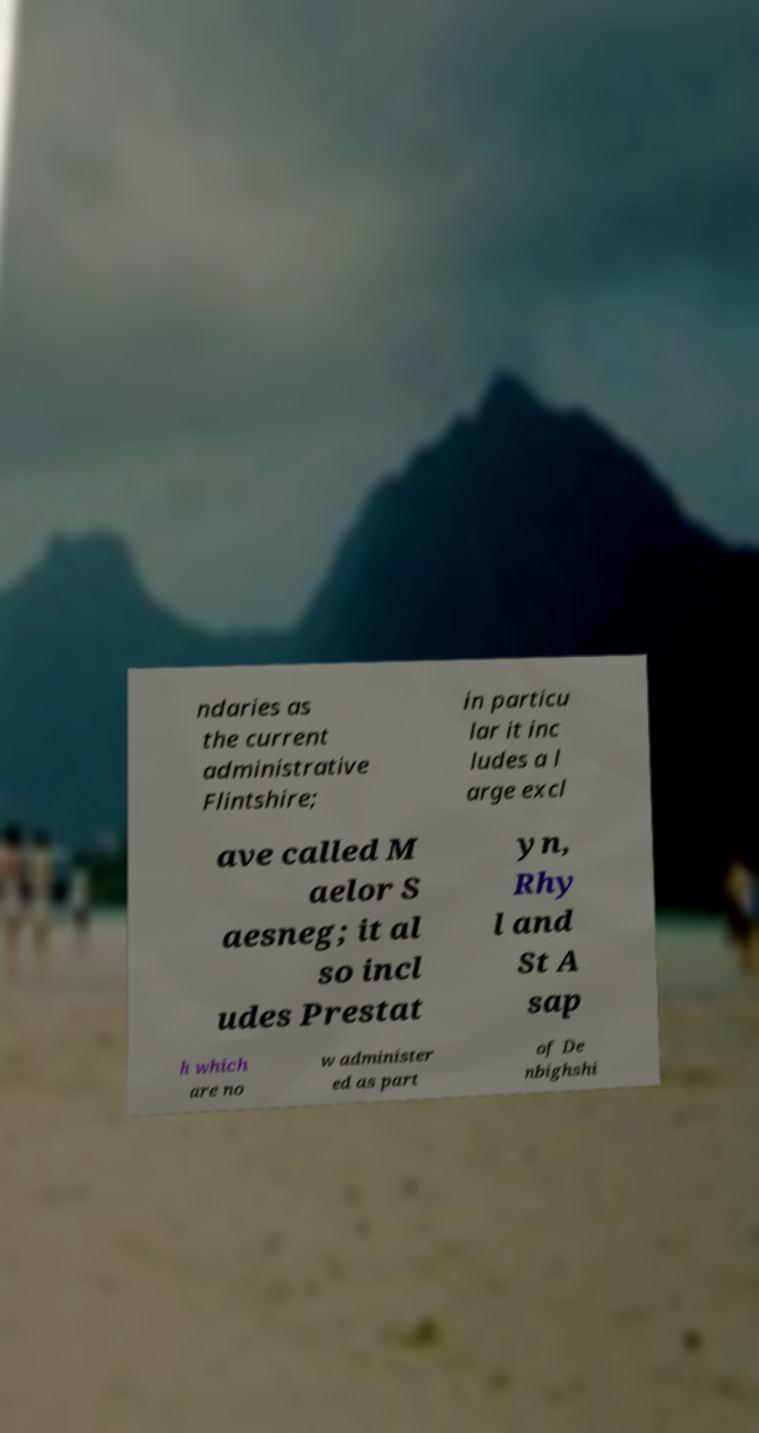Can you read and provide the text displayed in the image?This photo seems to have some interesting text. Can you extract and type it out for me? ndaries as the current administrative Flintshire; in particu lar it inc ludes a l arge excl ave called M aelor S aesneg; it al so incl udes Prestat yn, Rhy l and St A sap h which are no w administer ed as part of De nbighshi 